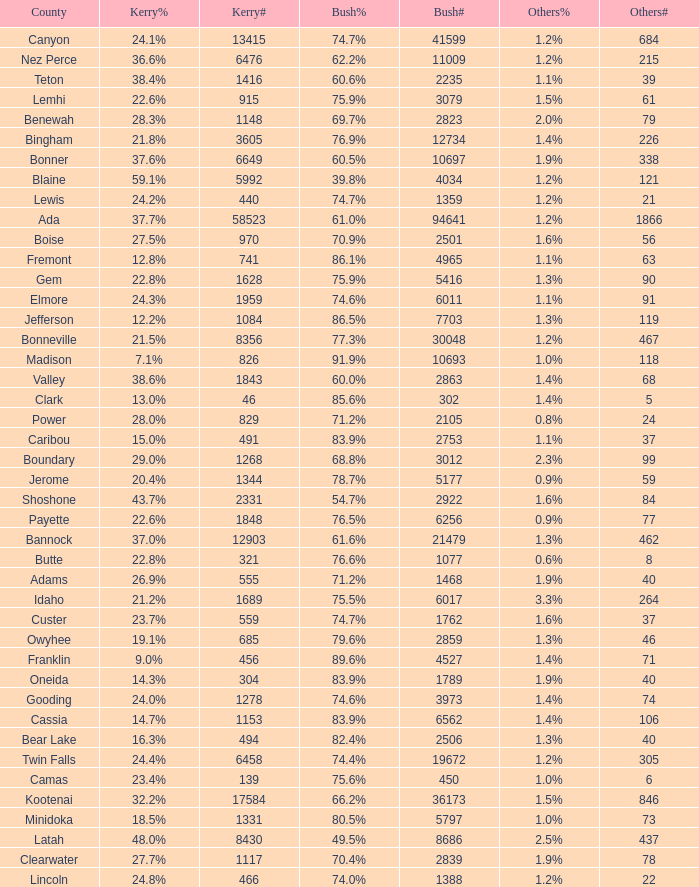How many people voted for Kerry in the county where 8 voted for others? 321.0. 